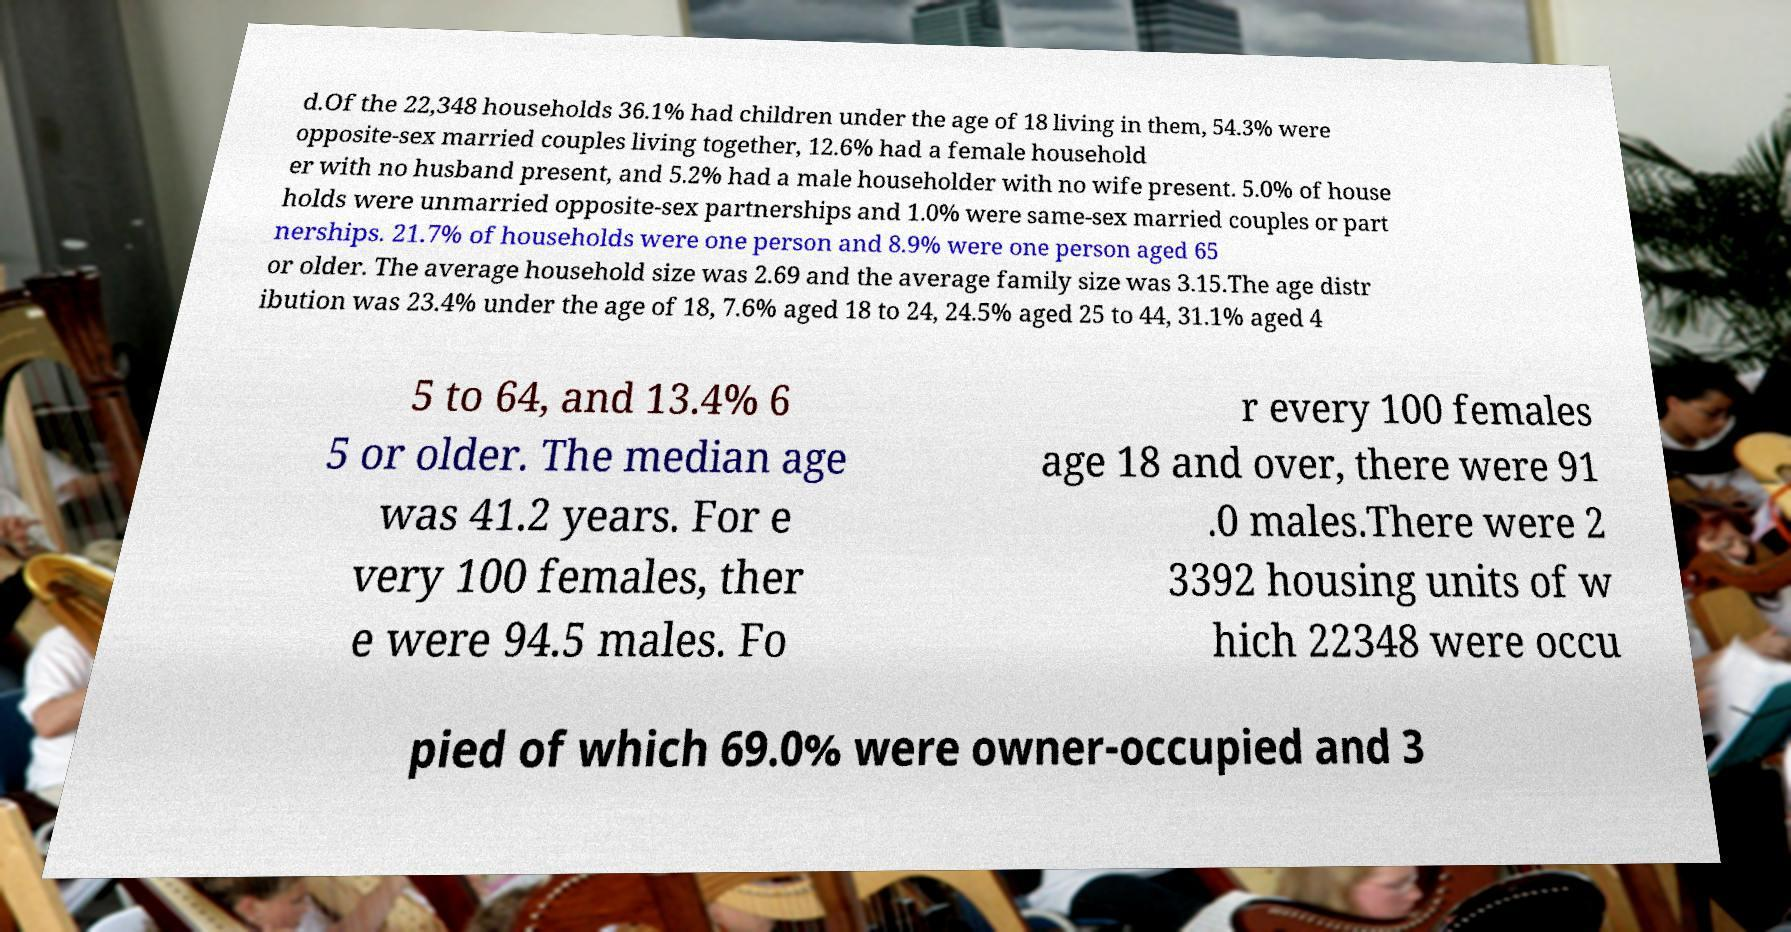Can you accurately transcribe the text from the provided image for me? d.Of the 22,348 households 36.1% had children under the age of 18 living in them, 54.3% were opposite-sex married couples living together, 12.6% had a female household er with no husband present, and 5.2% had a male householder with no wife present. 5.0% of house holds were unmarried opposite-sex partnerships and 1.0% were same-sex married couples or part nerships. 21.7% of households were one person and 8.9% were one person aged 65 or older. The average household size was 2.69 and the average family size was 3.15.The age distr ibution was 23.4% under the age of 18, 7.6% aged 18 to 24, 24.5% aged 25 to 44, 31.1% aged 4 5 to 64, and 13.4% 6 5 or older. The median age was 41.2 years. For e very 100 females, ther e were 94.5 males. Fo r every 100 females age 18 and over, there were 91 .0 males.There were 2 3392 housing units of w hich 22348 were occu pied of which 69.0% were owner-occupied and 3 